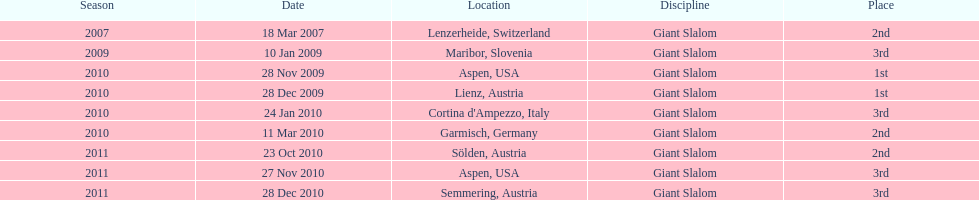The final race finishing place was not 1st but what other place? 3rd. 